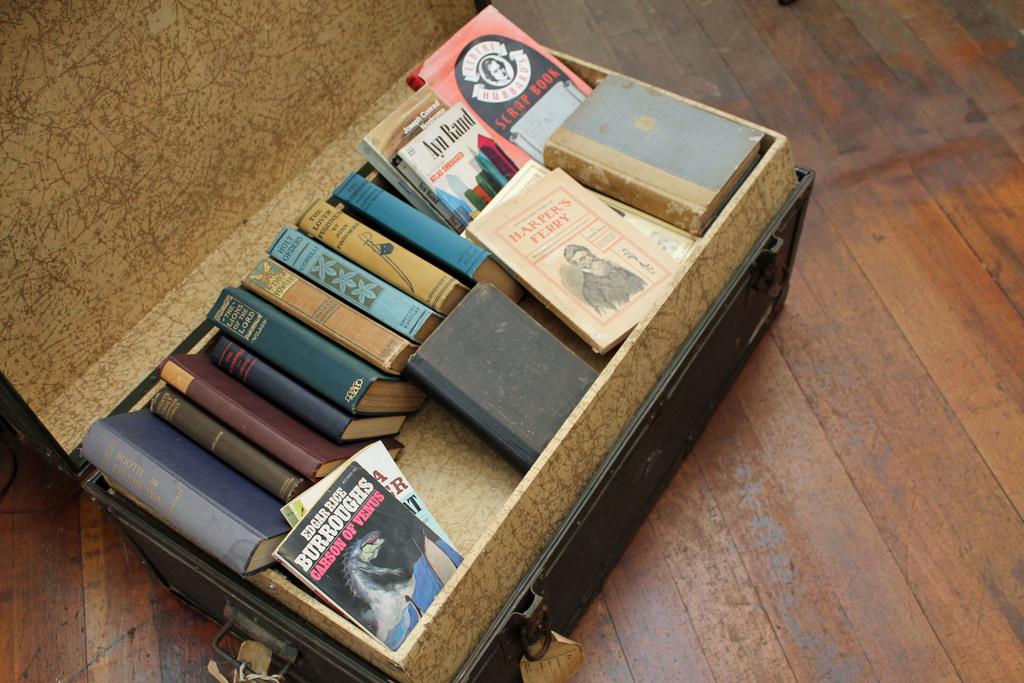Which one of these is by edgar rice?
Ensure brevity in your answer.  Carson of venus. 